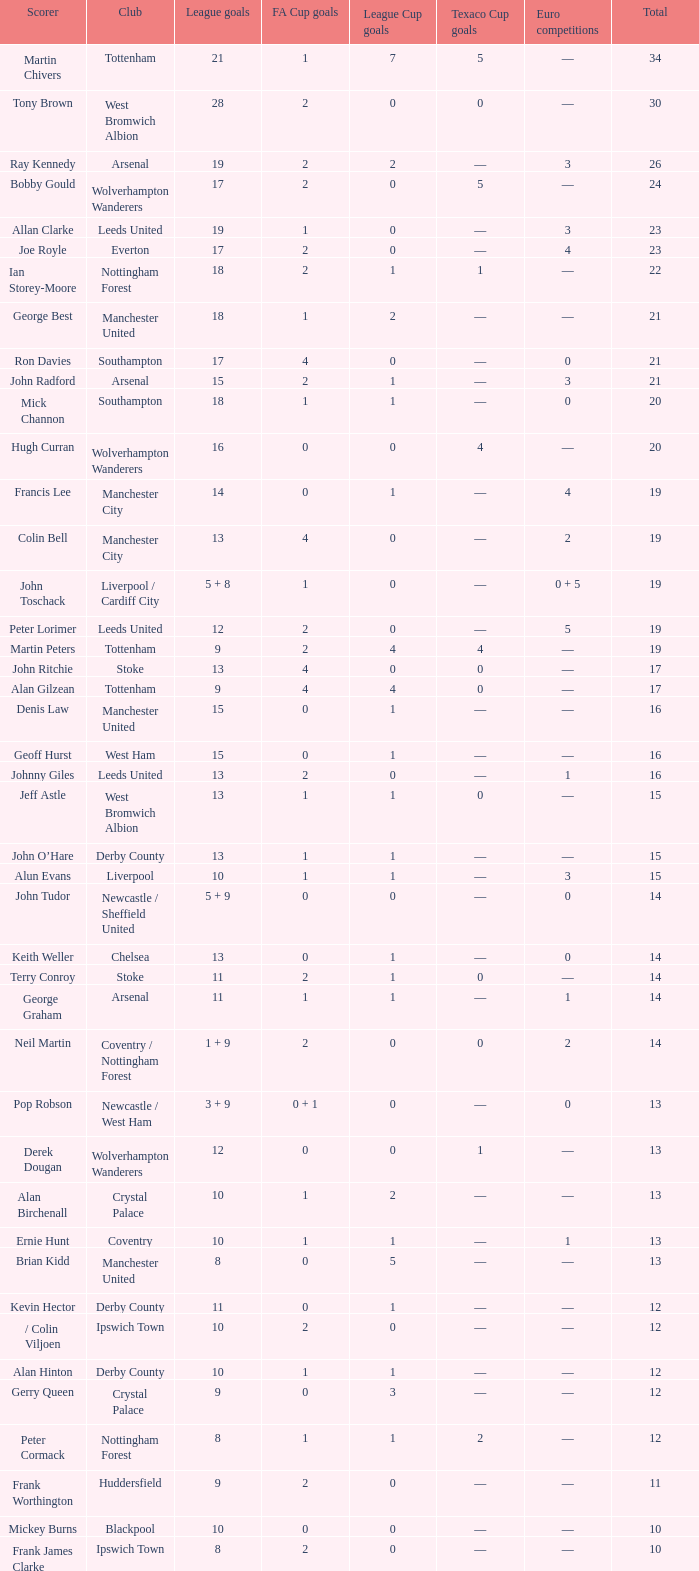What is the overall sum of total, when the club is leeds united, and league goals are 13? 1.0. Parse the full table. {'header': ['Scorer', 'Club', 'League goals', 'FA Cup goals', 'League Cup goals', 'Texaco Cup goals', 'Euro competitions', 'Total'], 'rows': [['Martin Chivers', 'Tottenham', '21', '1', '7', '5', '—', '34'], ['Tony Brown', 'West Bromwich Albion', '28', '2', '0', '0', '—', '30'], ['Ray Kennedy', 'Arsenal', '19', '2', '2', '—', '3', '26'], ['Bobby Gould', 'Wolverhampton Wanderers', '17', '2', '0', '5', '—', '24'], ['Allan Clarke', 'Leeds United', '19', '1', '0', '—', '3', '23'], ['Joe Royle', 'Everton', '17', '2', '0', '—', '4', '23'], ['Ian Storey-Moore', 'Nottingham Forest', '18', '2', '1', '1', '—', '22'], ['George Best', 'Manchester United', '18', '1', '2', '—', '—', '21'], ['Ron Davies', 'Southampton', '17', '4', '0', '—', '0', '21'], ['John Radford', 'Arsenal', '15', '2', '1', '—', '3', '21'], ['Mick Channon', 'Southampton', '18', '1', '1', '—', '0', '20'], ['Hugh Curran', 'Wolverhampton Wanderers', '16', '0', '0', '4', '—', '20'], ['Francis Lee', 'Manchester City', '14', '0', '1', '—', '4', '19'], ['Colin Bell', 'Manchester City', '13', '4', '0', '—', '2', '19'], ['John Toschack', 'Liverpool / Cardiff City', '5 + 8', '1', '0', '—', '0 + 5', '19'], ['Peter Lorimer', 'Leeds United', '12', '2', '0', '—', '5', '19'], ['Martin Peters', 'Tottenham', '9', '2', '4', '4', '—', '19'], ['John Ritchie', 'Stoke', '13', '4', '0', '0', '—', '17'], ['Alan Gilzean', 'Tottenham', '9', '4', '4', '0', '—', '17'], ['Denis Law', 'Manchester United', '15', '0', '1', '—', '—', '16'], ['Geoff Hurst', 'West Ham', '15', '0', '1', '—', '—', '16'], ['Johnny Giles', 'Leeds United', '13', '2', '0', '—', '1', '16'], ['Jeff Astle', 'West Bromwich Albion', '13', '1', '1', '0', '—', '15'], ['John O’Hare', 'Derby County', '13', '1', '1', '—', '—', '15'], ['Alun Evans', 'Liverpool', '10', '1', '1', '—', '3', '15'], ['John Tudor', 'Newcastle / Sheffield United', '5 + 9', '0', '0', '—', '0', '14'], ['Keith Weller', 'Chelsea', '13', '0', '1', '—', '0', '14'], ['Terry Conroy', 'Stoke', '11', '2', '1', '0', '—', '14'], ['George Graham', 'Arsenal', '11', '1', '1', '—', '1', '14'], ['Neil Martin', 'Coventry / Nottingham Forest', '1 + 9', '2', '0', '0', '2', '14'], ['Pop Robson', 'Newcastle / West Ham', '3 + 9', '0 + 1', '0', '—', '0', '13'], ['Derek Dougan', 'Wolverhampton Wanderers', '12', '0', '0', '1', '—', '13'], ['Alan Birchenall', 'Crystal Palace', '10', '1', '2', '—', '—', '13'], ['Ernie Hunt', 'Coventry', '10', '1', '1', '—', '1', '13'], ['Brian Kidd', 'Manchester United', '8', '0', '5', '—', '—', '13'], ['Kevin Hector', 'Derby County', '11', '0', '1', '—', '—', '12'], ['/ Colin Viljoen', 'Ipswich Town', '10', '2', '0', '—', '—', '12'], ['Alan Hinton', 'Derby County', '10', '1', '1', '—', '—', '12'], ['Gerry Queen', 'Crystal Palace', '9', '0', '3', '—', '—', '12'], ['Peter Cormack', 'Nottingham Forest', '8', '1', '1', '2', '—', '12'], ['Frank Worthington', 'Huddersfield', '9', '2', '0', '—', '—', '11'], ['Mickey Burns', 'Blackpool', '10', '0', '0', '—', '—', '10'], ['Frank James Clarke', 'Ipswich Town', '8', '2', '0', '—', '—', '10'], ['Jimmy Greenhoff', 'Stoke', '7', '3', '0', '0', '—', '10'], ['Charlie George', 'Arsenal', '5', '5', '0', '—', '0', '10']]} 